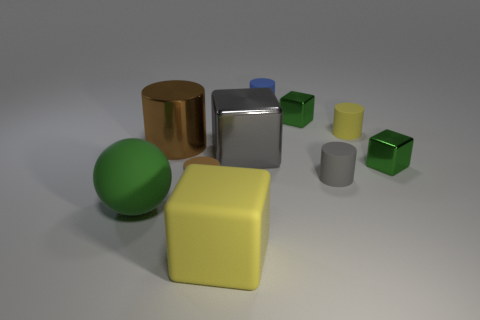Subtract all gray matte cylinders. How many cylinders are left? 4 Subtract all purple cubes. How many brown cylinders are left? 2 Subtract all balls. How many objects are left? 9 Subtract all blue cylinders. How many cylinders are left? 4 Subtract 1 balls. How many balls are left? 0 Subtract all gray blocks. Subtract all red spheres. How many blocks are left? 3 Subtract all tiny brown cylinders. Subtract all big rubber balls. How many objects are left? 8 Add 8 yellow matte blocks. How many yellow matte blocks are left? 9 Add 3 large metallic objects. How many large metallic objects exist? 5 Subtract 0 purple balls. How many objects are left? 10 